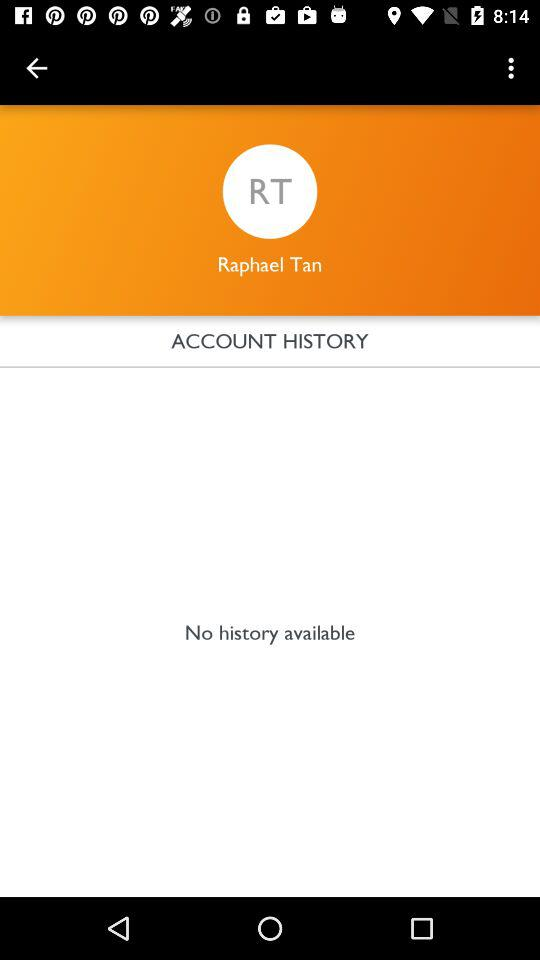What is the shown user name? The shown user name is Raphael Tan. 